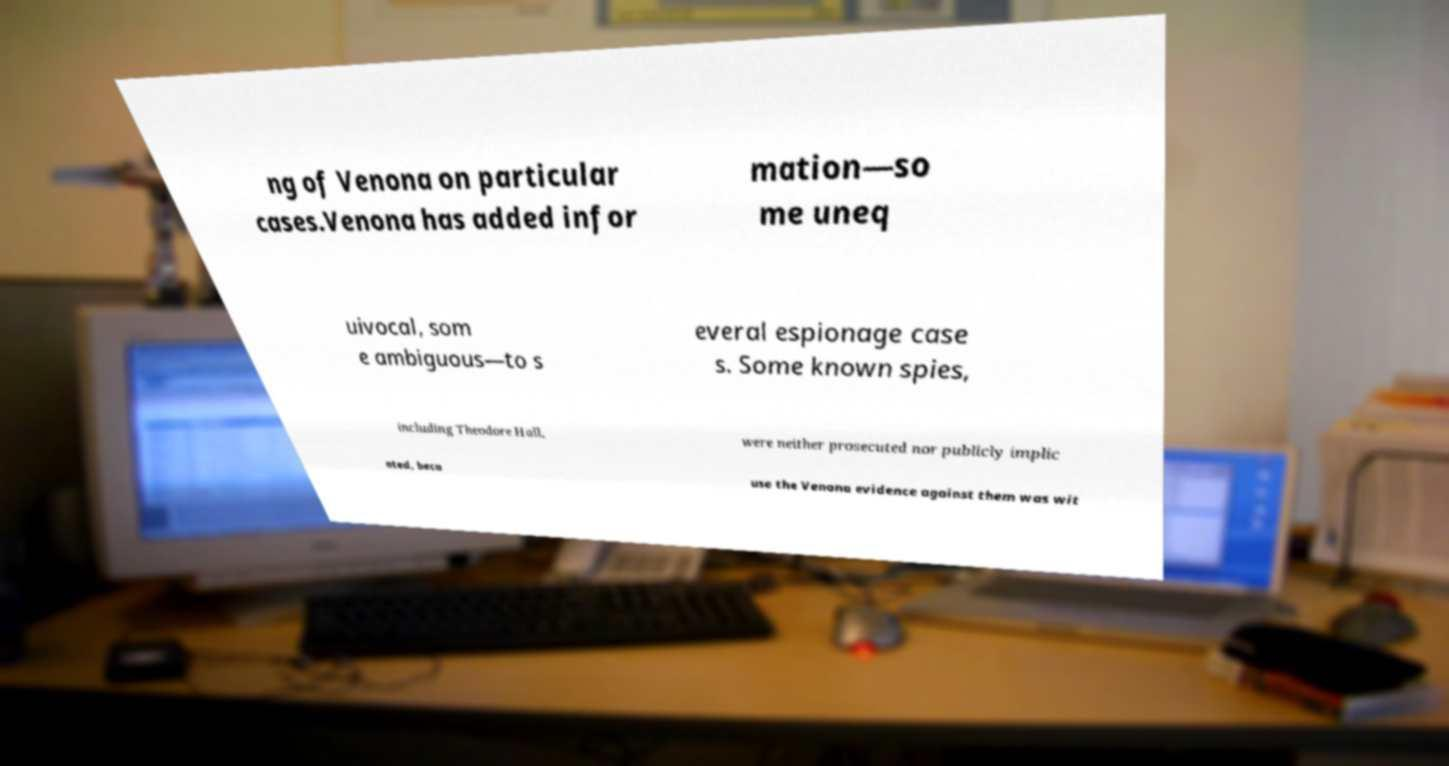Could you assist in decoding the text presented in this image and type it out clearly? ng of Venona on particular cases.Venona has added infor mation—so me uneq uivocal, som e ambiguous—to s everal espionage case s. Some known spies, including Theodore Hall, were neither prosecuted nor publicly implic ated, beca use the Venona evidence against them was wit 